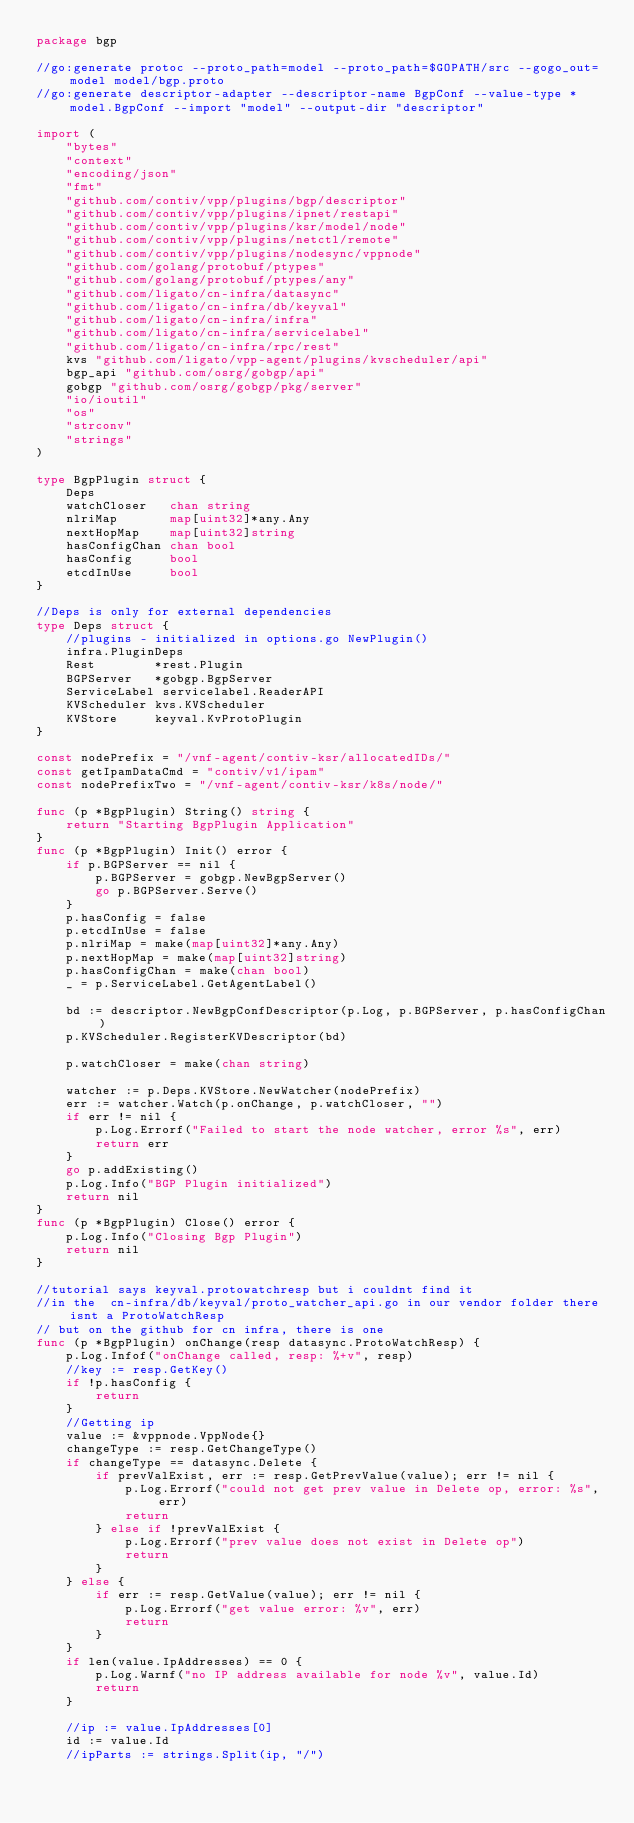<code> <loc_0><loc_0><loc_500><loc_500><_Go_>package bgp

//go:generate protoc --proto_path=model --proto_path=$GOPATH/src --gogo_out=model model/bgp.proto
//go:generate descriptor-adapter --descriptor-name BgpConf --value-type *model.BgpConf --import "model" --output-dir "descriptor"

import (
	"bytes"
	"context"
	"encoding/json"
	"fmt"
	"github.com/contiv/vpp/plugins/bgp/descriptor"
	"github.com/contiv/vpp/plugins/ipnet/restapi"
	"github.com/contiv/vpp/plugins/ksr/model/node"
	"github.com/contiv/vpp/plugins/netctl/remote"
	"github.com/contiv/vpp/plugins/nodesync/vppnode"
	"github.com/golang/protobuf/ptypes"
	"github.com/golang/protobuf/ptypes/any"
	"github.com/ligato/cn-infra/datasync"
	"github.com/ligato/cn-infra/db/keyval"
	"github.com/ligato/cn-infra/infra"
	"github.com/ligato/cn-infra/servicelabel"
	"github.com/ligato/cn-infra/rpc/rest"
	kvs "github.com/ligato/vpp-agent/plugins/kvscheduler/api"
	bgp_api "github.com/osrg/gobgp/api"
	gobgp "github.com/osrg/gobgp/pkg/server"
	"io/ioutil"
	"os"
	"strconv"
	"strings"
)

type BgpPlugin struct {
	Deps
	watchCloser   chan string
	nlriMap       map[uint32]*any.Any
	nextHopMap    map[uint32]string
	hasConfigChan chan bool
	hasConfig     bool
	etcdInUse     bool
}

//Deps is only for external dependencies
type Deps struct {
	//plugins - initialized in options.go NewPlugin()
	infra.PluginDeps
	Rest        *rest.Plugin
	BGPServer   *gobgp.BgpServer
	ServiceLabel servicelabel.ReaderAPI
	KVScheduler kvs.KVScheduler
	KVStore     keyval.KvProtoPlugin
}

const nodePrefix = "/vnf-agent/contiv-ksr/allocatedIDs/"
const getIpamDataCmd = "contiv/v1/ipam"
const nodePrefixTwo = "/vnf-agent/contiv-ksr/k8s/node/"

func (p *BgpPlugin) String() string {
	return "Starting BgpPlugin Application"
}
func (p *BgpPlugin) Init() error {
	if p.BGPServer == nil {
		p.BGPServer = gobgp.NewBgpServer()
		go p.BGPServer.Serve()
	}
	p.hasConfig = false
	p.etcdInUse = false
	p.nlriMap = make(map[uint32]*any.Any)
	p.nextHopMap = make(map[uint32]string)
	p.hasConfigChan = make(chan bool)
	_ = p.ServiceLabel.GetAgentLabel()

	bd := descriptor.NewBgpConfDescriptor(p.Log, p.BGPServer, p.hasConfigChan)
	p.KVScheduler.RegisterKVDescriptor(bd)

	p.watchCloser = make(chan string)

	watcher := p.Deps.KVStore.NewWatcher(nodePrefix)
	err := watcher.Watch(p.onChange, p.watchCloser, "")
	if err != nil {
		p.Log.Errorf("Failed to start the node watcher, error %s", err)
		return err
	}
	go p.addExisting()
	p.Log.Info("BGP Plugin initialized")
	return nil
}
func (p *BgpPlugin) Close() error {
	p.Log.Info("Closing Bgp Plugin")
	return nil
}

//tutorial says keyval.protowatchresp but i couldnt find it
//in the  cn-infra/db/keyval/proto_watcher_api.go in our vendor folder there isnt a ProtoWatchResp
// but on the github for cn infra, there is one
func (p *BgpPlugin) onChange(resp datasync.ProtoWatchResp) {
	p.Log.Infof("onChange called, resp: %+v", resp)
	//key := resp.GetKey()
	if !p.hasConfig {
		return
	}
	//Getting ip
	value := &vppnode.VppNode{}
	changeType := resp.GetChangeType()
	if changeType == datasync.Delete {
		if prevValExist, err := resp.GetPrevValue(value); err != nil {
			p.Log.Errorf("could not get prev value in Delete op, error: %s", err)
			return
		} else if !prevValExist {
			p.Log.Errorf("prev value does not exist in Delete op")
			return
		}
	} else {
		if err := resp.GetValue(value); err != nil {
			p.Log.Errorf("get value error: %v", err)
			return
		}
	}
	if len(value.IpAddresses) == 0 {
		p.Log.Warnf("no IP address available for node %v", value.Id)
		return
	}

	//ip := value.IpAddresses[0]
	id := value.Id
	//ipParts := strings.Split(ip, "/")</code> 